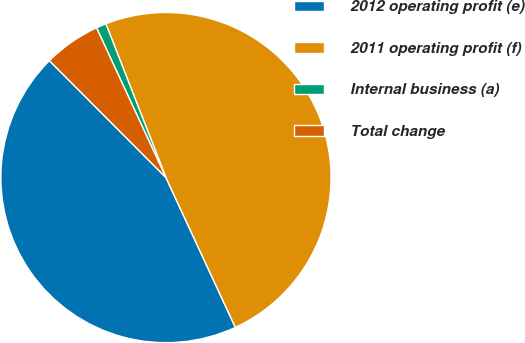Convert chart. <chart><loc_0><loc_0><loc_500><loc_500><pie_chart><fcel>2012 operating profit (e)<fcel>2011 operating profit (f)<fcel>Internal business (a)<fcel>Total change<nl><fcel>44.43%<fcel>49.02%<fcel>0.98%<fcel>5.57%<nl></chart> 